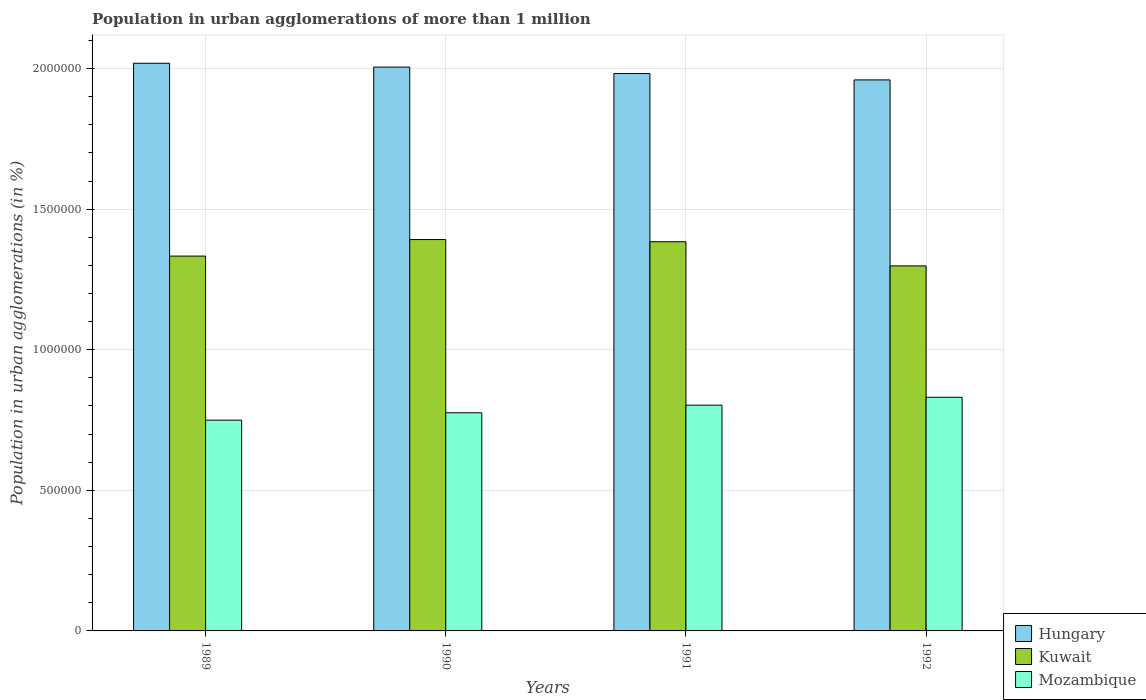Are the number of bars per tick equal to the number of legend labels?
Make the answer very short. Yes. In how many cases, is the number of bars for a given year not equal to the number of legend labels?
Keep it short and to the point. 0. What is the population in urban agglomerations in Mozambique in 1991?
Keep it short and to the point. 8.03e+05. Across all years, what is the maximum population in urban agglomerations in Hungary?
Give a very brief answer. 2.02e+06. Across all years, what is the minimum population in urban agglomerations in Mozambique?
Provide a short and direct response. 7.50e+05. In which year was the population in urban agglomerations in Kuwait minimum?
Provide a short and direct response. 1992. What is the total population in urban agglomerations in Mozambique in the graph?
Ensure brevity in your answer.  3.16e+06. What is the difference between the population in urban agglomerations in Kuwait in 1989 and that in 1991?
Offer a terse response. -5.10e+04. What is the difference between the population in urban agglomerations in Hungary in 1989 and the population in urban agglomerations in Mozambique in 1991?
Your answer should be compact. 1.22e+06. What is the average population in urban agglomerations in Kuwait per year?
Your answer should be compact. 1.35e+06. In the year 1992, what is the difference between the population in urban agglomerations in Hungary and population in urban agglomerations in Mozambique?
Offer a very short reply. 1.13e+06. What is the ratio of the population in urban agglomerations in Mozambique in 1990 to that in 1991?
Offer a very short reply. 0.97. Is the population in urban agglomerations in Hungary in 1990 less than that in 1991?
Your response must be concise. No. What is the difference between the highest and the second highest population in urban agglomerations in Mozambique?
Provide a succinct answer. 2.81e+04. What is the difference between the highest and the lowest population in urban agglomerations in Kuwait?
Offer a terse response. 9.37e+04. Is the sum of the population in urban agglomerations in Hungary in 1990 and 1991 greater than the maximum population in urban agglomerations in Mozambique across all years?
Offer a terse response. Yes. What does the 3rd bar from the left in 1991 represents?
Ensure brevity in your answer.  Mozambique. What does the 3rd bar from the right in 1989 represents?
Your answer should be very brief. Hungary. Is it the case that in every year, the sum of the population in urban agglomerations in Kuwait and population in urban agglomerations in Hungary is greater than the population in urban agglomerations in Mozambique?
Offer a terse response. Yes. How many bars are there?
Your answer should be very brief. 12. Are all the bars in the graph horizontal?
Ensure brevity in your answer.  No. What is the difference between two consecutive major ticks on the Y-axis?
Offer a terse response. 5.00e+05. How many legend labels are there?
Offer a terse response. 3. How are the legend labels stacked?
Make the answer very short. Vertical. What is the title of the graph?
Ensure brevity in your answer.  Population in urban agglomerations of more than 1 million. What is the label or title of the X-axis?
Ensure brevity in your answer.  Years. What is the label or title of the Y-axis?
Keep it short and to the point. Population in urban agglomerations (in %). What is the Population in urban agglomerations (in %) in Hungary in 1989?
Make the answer very short. 2.02e+06. What is the Population in urban agglomerations (in %) of Kuwait in 1989?
Your response must be concise. 1.33e+06. What is the Population in urban agglomerations (in %) of Mozambique in 1989?
Ensure brevity in your answer.  7.50e+05. What is the Population in urban agglomerations (in %) of Hungary in 1990?
Your answer should be compact. 2.01e+06. What is the Population in urban agglomerations (in %) of Kuwait in 1990?
Provide a short and direct response. 1.39e+06. What is the Population in urban agglomerations (in %) in Mozambique in 1990?
Provide a succinct answer. 7.76e+05. What is the Population in urban agglomerations (in %) in Hungary in 1991?
Offer a terse response. 1.98e+06. What is the Population in urban agglomerations (in %) of Kuwait in 1991?
Your answer should be very brief. 1.38e+06. What is the Population in urban agglomerations (in %) in Mozambique in 1991?
Provide a short and direct response. 8.03e+05. What is the Population in urban agglomerations (in %) of Hungary in 1992?
Your answer should be compact. 1.96e+06. What is the Population in urban agglomerations (in %) in Kuwait in 1992?
Your answer should be compact. 1.30e+06. What is the Population in urban agglomerations (in %) of Mozambique in 1992?
Provide a succinct answer. 8.31e+05. Across all years, what is the maximum Population in urban agglomerations (in %) of Hungary?
Provide a succinct answer. 2.02e+06. Across all years, what is the maximum Population in urban agglomerations (in %) of Kuwait?
Give a very brief answer. 1.39e+06. Across all years, what is the maximum Population in urban agglomerations (in %) in Mozambique?
Your answer should be compact. 8.31e+05. Across all years, what is the minimum Population in urban agglomerations (in %) in Hungary?
Provide a succinct answer. 1.96e+06. Across all years, what is the minimum Population in urban agglomerations (in %) of Kuwait?
Keep it short and to the point. 1.30e+06. Across all years, what is the minimum Population in urban agglomerations (in %) of Mozambique?
Offer a terse response. 7.50e+05. What is the total Population in urban agglomerations (in %) in Hungary in the graph?
Your response must be concise. 7.97e+06. What is the total Population in urban agglomerations (in %) of Kuwait in the graph?
Your answer should be compact. 5.41e+06. What is the total Population in urban agglomerations (in %) in Mozambique in the graph?
Offer a very short reply. 3.16e+06. What is the difference between the Population in urban agglomerations (in %) in Hungary in 1989 and that in 1990?
Keep it short and to the point. 1.36e+04. What is the difference between the Population in urban agglomerations (in %) in Kuwait in 1989 and that in 1990?
Offer a terse response. -5.88e+04. What is the difference between the Population in urban agglomerations (in %) in Mozambique in 1989 and that in 1990?
Make the answer very short. -2.62e+04. What is the difference between the Population in urban agglomerations (in %) of Hungary in 1989 and that in 1991?
Offer a terse response. 3.65e+04. What is the difference between the Population in urban agglomerations (in %) of Kuwait in 1989 and that in 1991?
Make the answer very short. -5.10e+04. What is the difference between the Population in urban agglomerations (in %) in Mozambique in 1989 and that in 1991?
Your response must be concise. -5.33e+04. What is the difference between the Population in urban agglomerations (in %) in Hungary in 1989 and that in 1992?
Provide a succinct answer. 5.92e+04. What is the difference between the Population in urban agglomerations (in %) of Kuwait in 1989 and that in 1992?
Make the answer very short. 3.49e+04. What is the difference between the Population in urban agglomerations (in %) in Mozambique in 1989 and that in 1992?
Offer a terse response. -8.14e+04. What is the difference between the Population in urban agglomerations (in %) in Hungary in 1990 and that in 1991?
Ensure brevity in your answer.  2.29e+04. What is the difference between the Population in urban agglomerations (in %) in Kuwait in 1990 and that in 1991?
Your answer should be very brief. 7756. What is the difference between the Population in urban agglomerations (in %) in Mozambique in 1990 and that in 1991?
Your answer should be very brief. -2.71e+04. What is the difference between the Population in urban agglomerations (in %) in Hungary in 1990 and that in 1992?
Make the answer very short. 4.56e+04. What is the difference between the Population in urban agglomerations (in %) in Kuwait in 1990 and that in 1992?
Ensure brevity in your answer.  9.37e+04. What is the difference between the Population in urban agglomerations (in %) of Mozambique in 1990 and that in 1992?
Give a very brief answer. -5.52e+04. What is the difference between the Population in urban agglomerations (in %) of Hungary in 1991 and that in 1992?
Offer a terse response. 2.27e+04. What is the difference between the Population in urban agglomerations (in %) in Kuwait in 1991 and that in 1992?
Ensure brevity in your answer.  8.60e+04. What is the difference between the Population in urban agglomerations (in %) of Mozambique in 1991 and that in 1992?
Your answer should be compact. -2.81e+04. What is the difference between the Population in urban agglomerations (in %) in Hungary in 1989 and the Population in urban agglomerations (in %) in Kuwait in 1990?
Your response must be concise. 6.27e+05. What is the difference between the Population in urban agglomerations (in %) in Hungary in 1989 and the Population in urban agglomerations (in %) in Mozambique in 1990?
Your answer should be compact. 1.24e+06. What is the difference between the Population in urban agglomerations (in %) in Kuwait in 1989 and the Population in urban agglomerations (in %) in Mozambique in 1990?
Your answer should be compact. 5.57e+05. What is the difference between the Population in urban agglomerations (in %) of Hungary in 1989 and the Population in urban agglomerations (in %) of Kuwait in 1991?
Give a very brief answer. 6.35e+05. What is the difference between the Population in urban agglomerations (in %) of Hungary in 1989 and the Population in urban agglomerations (in %) of Mozambique in 1991?
Offer a terse response. 1.22e+06. What is the difference between the Population in urban agglomerations (in %) of Kuwait in 1989 and the Population in urban agglomerations (in %) of Mozambique in 1991?
Your answer should be compact. 5.30e+05. What is the difference between the Population in urban agglomerations (in %) in Hungary in 1989 and the Population in urban agglomerations (in %) in Kuwait in 1992?
Keep it short and to the point. 7.21e+05. What is the difference between the Population in urban agglomerations (in %) in Hungary in 1989 and the Population in urban agglomerations (in %) in Mozambique in 1992?
Ensure brevity in your answer.  1.19e+06. What is the difference between the Population in urban agglomerations (in %) in Kuwait in 1989 and the Population in urban agglomerations (in %) in Mozambique in 1992?
Offer a terse response. 5.02e+05. What is the difference between the Population in urban agglomerations (in %) in Hungary in 1990 and the Population in urban agglomerations (in %) in Kuwait in 1991?
Your answer should be very brief. 6.21e+05. What is the difference between the Population in urban agglomerations (in %) in Hungary in 1990 and the Population in urban agglomerations (in %) in Mozambique in 1991?
Your answer should be very brief. 1.20e+06. What is the difference between the Population in urban agglomerations (in %) in Kuwait in 1990 and the Population in urban agglomerations (in %) in Mozambique in 1991?
Offer a very short reply. 5.89e+05. What is the difference between the Population in urban agglomerations (in %) of Hungary in 1990 and the Population in urban agglomerations (in %) of Kuwait in 1992?
Give a very brief answer. 7.07e+05. What is the difference between the Population in urban agglomerations (in %) of Hungary in 1990 and the Population in urban agglomerations (in %) of Mozambique in 1992?
Provide a short and direct response. 1.17e+06. What is the difference between the Population in urban agglomerations (in %) of Kuwait in 1990 and the Population in urban agglomerations (in %) of Mozambique in 1992?
Your answer should be compact. 5.61e+05. What is the difference between the Population in urban agglomerations (in %) of Hungary in 1991 and the Population in urban agglomerations (in %) of Kuwait in 1992?
Make the answer very short. 6.84e+05. What is the difference between the Population in urban agglomerations (in %) in Hungary in 1991 and the Population in urban agglomerations (in %) in Mozambique in 1992?
Your response must be concise. 1.15e+06. What is the difference between the Population in urban agglomerations (in %) of Kuwait in 1991 and the Population in urban agglomerations (in %) of Mozambique in 1992?
Your answer should be compact. 5.53e+05. What is the average Population in urban agglomerations (in %) of Hungary per year?
Give a very brief answer. 1.99e+06. What is the average Population in urban agglomerations (in %) of Kuwait per year?
Provide a short and direct response. 1.35e+06. What is the average Population in urban agglomerations (in %) of Mozambique per year?
Provide a short and direct response. 7.90e+05. In the year 1989, what is the difference between the Population in urban agglomerations (in %) of Hungary and Population in urban agglomerations (in %) of Kuwait?
Keep it short and to the point. 6.86e+05. In the year 1989, what is the difference between the Population in urban agglomerations (in %) of Hungary and Population in urban agglomerations (in %) of Mozambique?
Offer a terse response. 1.27e+06. In the year 1989, what is the difference between the Population in urban agglomerations (in %) in Kuwait and Population in urban agglomerations (in %) in Mozambique?
Provide a succinct answer. 5.83e+05. In the year 1990, what is the difference between the Population in urban agglomerations (in %) in Hungary and Population in urban agglomerations (in %) in Kuwait?
Your response must be concise. 6.13e+05. In the year 1990, what is the difference between the Population in urban agglomerations (in %) in Hungary and Population in urban agglomerations (in %) in Mozambique?
Keep it short and to the point. 1.23e+06. In the year 1990, what is the difference between the Population in urban agglomerations (in %) in Kuwait and Population in urban agglomerations (in %) in Mozambique?
Ensure brevity in your answer.  6.16e+05. In the year 1991, what is the difference between the Population in urban agglomerations (in %) of Hungary and Population in urban agglomerations (in %) of Kuwait?
Your answer should be compact. 5.98e+05. In the year 1991, what is the difference between the Population in urban agglomerations (in %) in Hungary and Population in urban agglomerations (in %) in Mozambique?
Provide a short and direct response. 1.18e+06. In the year 1991, what is the difference between the Population in urban agglomerations (in %) in Kuwait and Population in urban agglomerations (in %) in Mozambique?
Give a very brief answer. 5.81e+05. In the year 1992, what is the difference between the Population in urban agglomerations (in %) of Hungary and Population in urban agglomerations (in %) of Kuwait?
Your response must be concise. 6.61e+05. In the year 1992, what is the difference between the Population in urban agglomerations (in %) in Hungary and Population in urban agglomerations (in %) in Mozambique?
Make the answer very short. 1.13e+06. In the year 1992, what is the difference between the Population in urban agglomerations (in %) in Kuwait and Population in urban agglomerations (in %) in Mozambique?
Provide a short and direct response. 4.67e+05. What is the ratio of the Population in urban agglomerations (in %) of Hungary in 1989 to that in 1990?
Ensure brevity in your answer.  1.01. What is the ratio of the Population in urban agglomerations (in %) in Kuwait in 1989 to that in 1990?
Give a very brief answer. 0.96. What is the ratio of the Population in urban agglomerations (in %) in Mozambique in 1989 to that in 1990?
Your answer should be compact. 0.97. What is the ratio of the Population in urban agglomerations (in %) of Hungary in 1989 to that in 1991?
Offer a terse response. 1.02. What is the ratio of the Population in urban agglomerations (in %) of Kuwait in 1989 to that in 1991?
Keep it short and to the point. 0.96. What is the ratio of the Population in urban agglomerations (in %) of Mozambique in 1989 to that in 1991?
Make the answer very short. 0.93. What is the ratio of the Population in urban agglomerations (in %) in Hungary in 1989 to that in 1992?
Your answer should be compact. 1.03. What is the ratio of the Population in urban agglomerations (in %) in Kuwait in 1989 to that in 1992?
Your response must be concise. 1.03. What is the ratio of the Population in urban agglomerations (in %) of Mozambique in 1989 to that in 1992?
Your answer should be compact. 0.9. What is the ratio of the Population in urban agglomerations (in %) in Hungary in 1990 to that in 1991?
Your response must be concise. 1.01. What is the ratio of the Population in urban agglomerations (in %) in Kuwait in 1990 to that in 1991?
Provide a succinct answer. 1.01. What is the ratio of the Population in urban agglomerations (in %) of Mozambique in 1990 to that in 1991?
Make the answer very short. 0.97. What is the ratio of the Population in urban agglomerations (in %) in Hungary in 1990 to that in 1992?
Offer a very short reply. 1.02. What is the ratio of the Population in urban agglomerations (in %) in Kuwait in 1990 to that in 1992?
Provide a succinct answer. 1.07. What is the ratio of the Population in urban agglomerations (in %) of Mozambique in 1990 to that in 1992?
Ensure brevity in your answer.  0.93. What is the ratio of the Population in urban agglomerations (in %) in Hungary in 1991 to that in 1992?
Give a very brief answer. 1.01. What is the ratio of the Population in urban agglomerations (in %) of Kuwait in 1991 to that in 1992?
Your answer should be very brief. 1.07. What is the ratio of the Population in urban agglomerations (in %) in Mozambique in 1991 to that in 1992?
Offer a very short reply. 0.97. What is the difference between the highest and the second highest Population in urban agglomerations (in %) of Hungary?
Offer a terse response. 1.36e+04. What is the difference between the highest and the second highest Population in urban agglomerations (in %) in Kuwait?
Give a very brief answer. 7756. What is the difference between the highest and the second highest Population in urban agglomerations (in %) of Mozambique?
Your answer should be compact. 2.81e+04. What is the difference between the highest and the lowest Population in urban agglomerations (in %) of Hungary?
Your answer should be compact. 5.92e+04. What is the difference between the highest and the lowest Population in urban agglomerations (in %) in Kuwait?
Your answer should be very brief. 9.37e+04. What is the difference between the highest and the lowest Population in urban agglomerations (in %) in Mozambique?
Your answer should be very brief. 8.14e+04. 